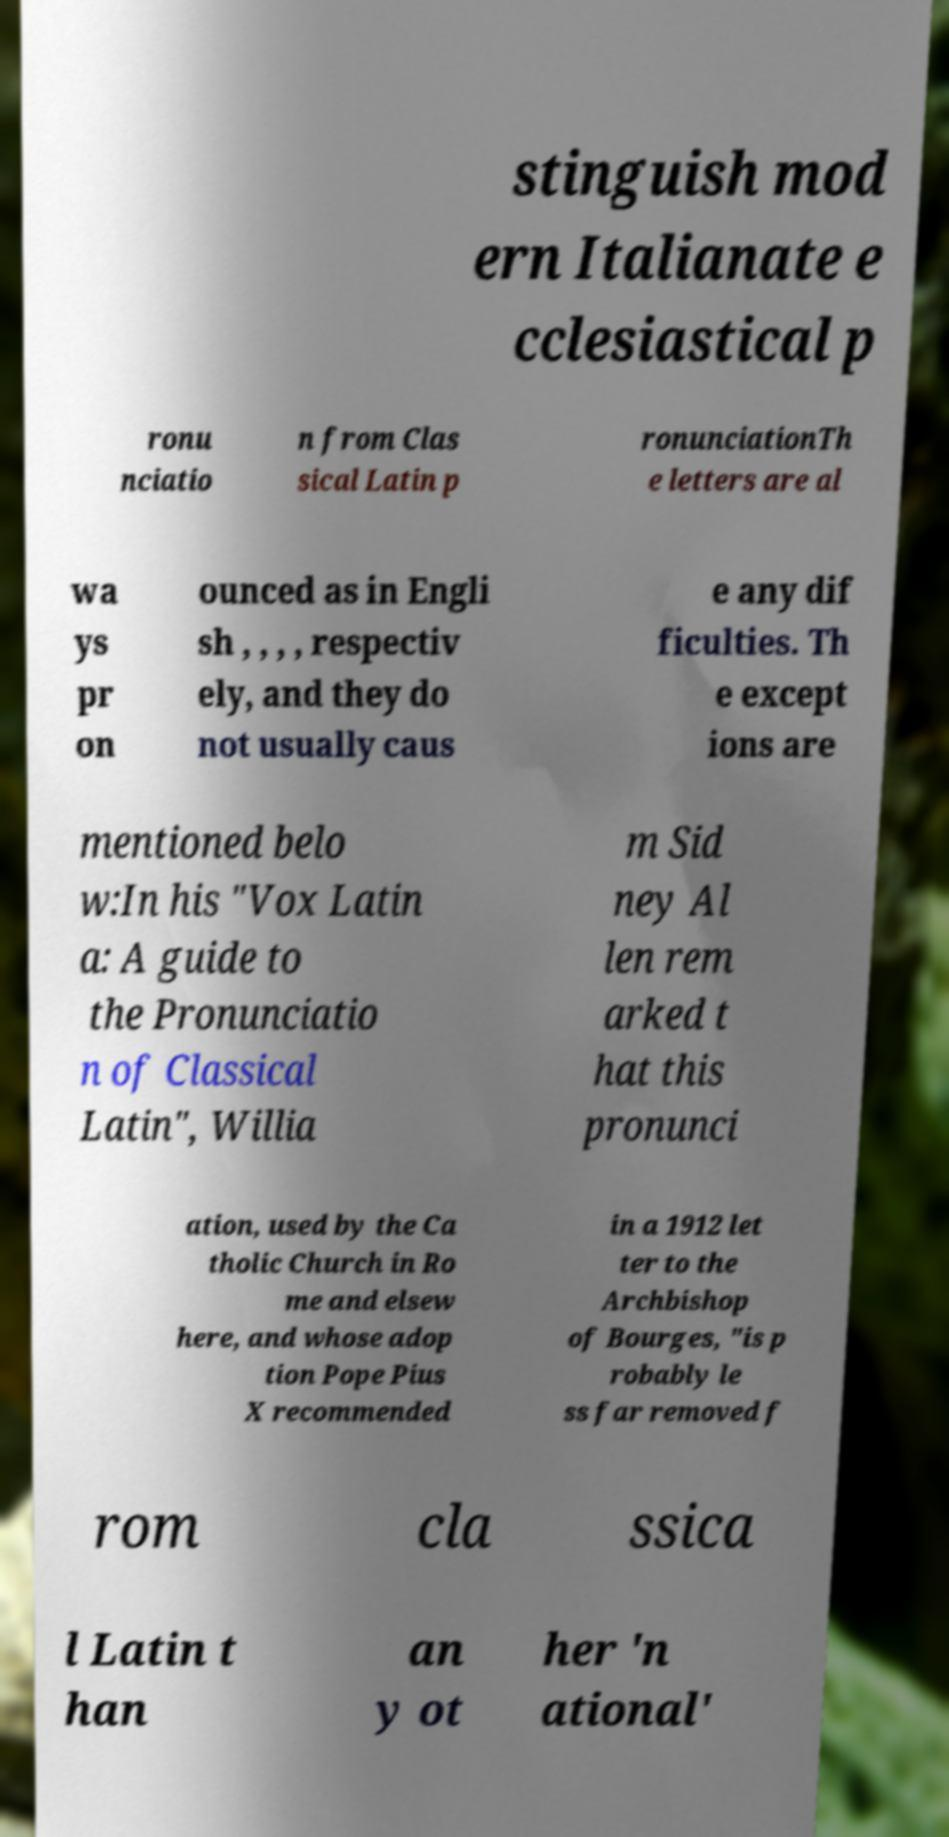Please identify and transcribe the text found in this image. stinguish mod ern Italianate e cclesiastical p ronu nciatio n from Clas sical Latin p ronunciationTh e letters are al wa ys pr on ounced as in Engli sh , , , , respectiv ely, and they do not usually caus e any dif ficulties. Th e except ions are mentioned belo w:In his "Vox Latin a: A guide to the Pronunciatio n of Classical Latin", Willia m Sid ney Al len rem arked t hat this pronunci ation, used by the Ca tholic Church in Ro me and elsew here, and whose adop tion Pope Pius X recommended in a 1912 let ter to the Archbishop of Bourges, "is p robably le ss far removed f rom cla ssica l Latin t han an y ot her 'n ational' 